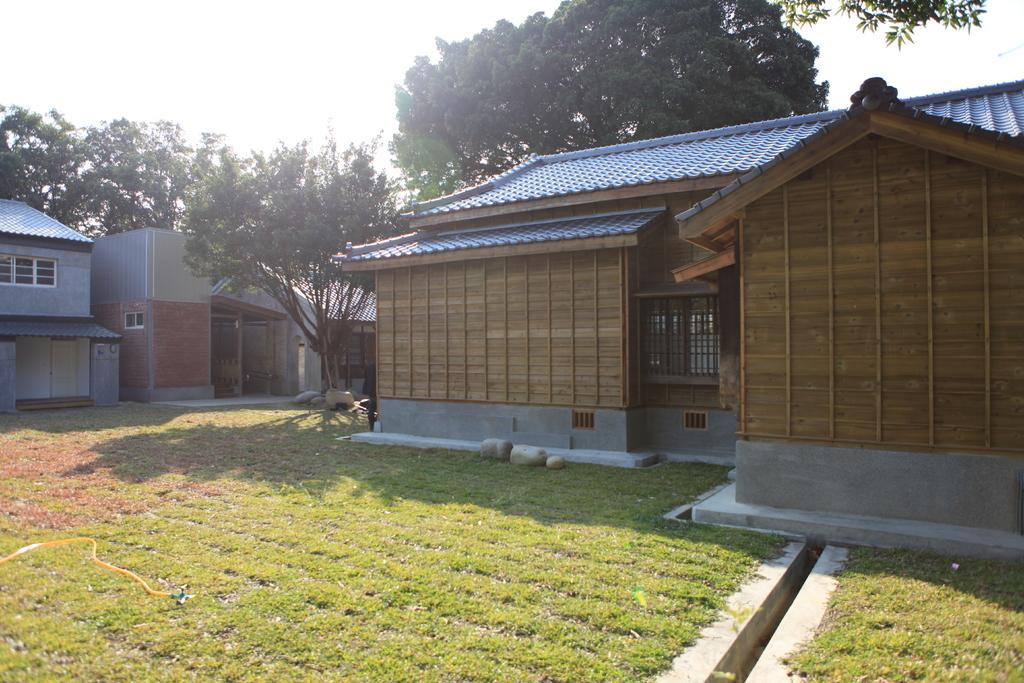What type of ground surface is visible in the image? There is grass on the ground in the image. What object can be seen in the grass? There is a pipe in the grass. What can be seen in the distance in the image? There are trees and houses visible in the background of the image. What top was discovered in the grass in the image? There is no top present in the image; it is a pipe that can be seen in the grass. 